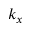Convert formula to latex. <formula><loc_0><loc_0><loc_500><loc_500>k _ { x }</formula> 